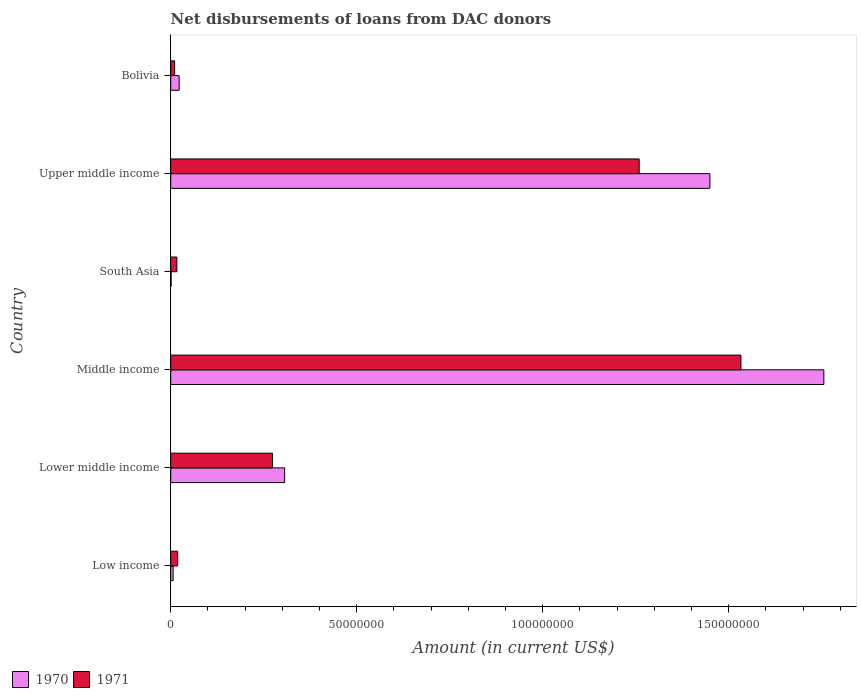Are the number of bars per tick equal to the number of legend labels?
Make the answer very short. Yes. How many bars are there on the 1st tick from the top?
Your answer should be compact. 2. How many bars are there on the 4th tick from the bottom?
Offer a very short reply. 2. What is the label of the 6th group of bars from the top?
Your answer should be very brief. Low income. In how many cases, is the number of bars for a given country not equal to the number of legend labels?
Your response must be concise. 0. What is the amount of loans disbursed in 1971 in Upper middle income?
Ensure brevity in your answer.  1.26e+08. Across all countries, what is the maximum amount of loans disbursed in 1970?
Your response must be concise. 1.76e+08. Across all countries, what is the minimum amount of loans disbursed in 1971?
Ensure brevity in your answer.  1.06e+06. In which country was the amount of loans disbursed in 1971 maximum?
Offer a very short reply. Middle income. What is the total amount of loans disbursed in 1970 in the graph?
Offer a terse response. 3.54e+08. What is the difference between the amount of loans disbursed in 1971 in Low income and that in Lower middle income?
Offer a terse response. -2.55e+07. What is the difference between the amount of loans disbursed in 1970 in Low income and the amount of loans disbursed in 1971 in Upper middle income?
Provide a short and direct response. -1.25e+08. What is the average amount of loans disbursed in 1970 per country?
Provide a short and direct response. 5.90e+07. What is the difference between the amount of loans disbursed in 1971 and amount of loans disbursed in 1970 in Middle income?
Provide a short and direct response. -2.23e+07. What is the ratio of the amount of loans disbursed in 1971 in Bolivia to that in Middle income?
Offer a terse response. 0.01. What is the difference between the highest and the second highest amount of loans disbursed in 1970?
Provide a succinct answer. 3.06e+07. What is the difference between the highest and the lowest amount of loans disbursed in 1971?
Provide a succinct answer. 1.52e+08. Is the sum of the amount of loans disbursed in 1971 in Lower middle income and Middle income greater than the maximum amount of loans disbursed in 1970 across all countries?
Keep it short and to the point. Yes. What does the 1st bar from the top in Bolivia represents?
Provide a short and direct response. 1971. What does the 2nd bar from the bottom in Lower middle income represents?
Keep it short and to the point. 1971. How many bars are there?
Keep it short and to the point. 12. Are all the bars in the graph horizontal?
Your answer should be very brief. Yes. How many countries are there in the graph?
Provide a succinct answer. 6. Does the graph contain any zero values?
Give a very brief answer. No. Does the graph contain grids?
Make the answer very short. No. Where does the legend appear in the graph?
Keep it short and to the point. Bottom left. What is the title of the graph?
Offer a terse response. Net disbursements of loans from DAC donors. What is the Amount (in current US$) in 1970 in Low income?
Make the answer very short. 6.47e+05. What is the Amount (in current US$) of 1971 in Low income?
Offer a very short reply. 1.86e+06. What is the Amount (in current US$) in 1970 in Lower middle income?
Provide a short and direct response. 3.06e+07. What is the Amount (in current US$) in 1971 in Lower middle income?
Your answer should be compact. 2.74e+07. What is the Amount (in current US$) of 1970 in Middle income?
Your answer should be compact. 1.76e+08. What is the Amount (in current US$) of 1971 in Middle income?
Make the answer very short. 1.53e+08. What is the Amount (in current US$) of 1970 in South Asia?
Your answer should be compact. 1.09e+05. What is the Amount (in current US$) in 1971 in South Asia?
Your answer should be very brief. 1.65e+06. What is the Amount (in current US$) of 1970 in Upper middle income?
Your answer should be compact. 1.45e+08. What is the Amount (in current US$) of 1971 in Upper middle income?
Offer a very short reply. 1.26e+08. What is the Amount (in current US$) of 1970 in Bolivia?
Make the answer very short. 2.27e+06. What is the Amount (in current US$) in 1971 in Bolivia?
Make the answer very short. 1.06e+06. Across all countries, what is the maximum Amount (in current US$) in 1970?
Make the answer very short. 1.76e+08. Across all countries, what is the maximum Amount (in current US$) in 1971?
Give a very brief answer. 1.53e+08. Across all countries, what is the minimum Amount (in current US$) in 1970?
Ensure brevity in your answer.  1.09e+05. Across all countries, what is the minimum Amount (in current US$) in 1971?
Your answer should be very brief. 1.06e+06. What is the total Amount (in current US$) in 1970 in the graph?
Ensure brevity in your answer.  3.54e+08. What is the total Amount (in current US$) in 1971 in the graph?
Offer a very short reply. 3.11e+08. What is the difference between the Amount (in current US$) in 1970 in Low income and that in Lower middle income?
Your response must be concise. -3.00e+07. What is the difference between the Amount (in current US$) of 1971 in Low income and that in Lower middle income?
Offer a very short reply. -2.55e+07. What is the difference between the Amount (in current US$) of 1970 in Low income and that in Middle income?
Your answer should be very brief. -1.75e+08. What is the difference between the Amount (in current US$) of 1971 in Low income and that in Middle income?
Keep it short and to the point. -1.51e+08. What is the difference between the Amount (in current US$) in 1970 in Low income and that in South Asia?
Keep it short and to the point. 5.38e+05. What is the difference between the Amount (in current US$) in 1971 in Low income and that in South Asia?
Your response must be concise. 2.09e+05. What is the difference between the Amount (in current US$) in 1970 in Low income and that in Upper middle income?
Provide a succinct answer. -1.44e+08. What is the difference between the Amount (in current US$) of 1971 in Low income and that in Upper middle income?
Provide a succinct answer. -1.24e+08. What is the difference between the Amount (in current US$) in 1970 in Low income and that in Bolivia?
Keep it short and to the point. -1.62e+06. What is the difference between the Amount (in current US$) in 1971 in Low income and that in Bolivia?
Your answer should be compact. 8.01e+05. What is the difference between the Amount (in current US$) of 1970 in Lower middle income and that in Middle income?
Your response must be concise. -1.45e+08. What is the difference between the Amount (in current US$) of 1971 in Lower middle income and that in Middle income?
Keep it short and to the point. -1.26e+08. What is the difference between the Amount (in current US$) in 1970 in Lower middle income and that in South Asia?
Keep it short and to the point. 3.05e+07. What is the difference between the Amount (in current US$) of 1971 in Lower middle income and that in South Asia?
Keep it short and to the point. 2.57e+07. What is the difference between the Amount (in current US$) in 1970 in Lower middle income and that in Upper middle income?
Offer a terse response. -1.14e+08. What is the difference between the Amount (in current US$) in 1971 in Lower middle income and that in Upper middle income?
Provide a succinct answer. -9.86e+07. What is the difference between the Amount (in current US$) in 1970 in Lower middle income and that in Bolivia?
Ensure brevity in your answer.  2.84e+07. What is the difference between the Amount (in current US$) in 1971 in Lower middle income and that in Bolivia?
Provide a succinct answer. 2.63e+07. What is the difference between the Amount (in current US$) in 1970 in Middle income and that in South Asia?
Ensure brevity in your answer.  1.75e+08. What is the difference between the Amount (in current US$) in 1971 in Middle income and that in South Asia?
Give a very brief answer. 1.52e+08. What is the difference between the Amount (in current US$) of 1970 in Middle income and that in Upper middle income?
Ensure brevity in your answer.  3.06e+07. What is the difference between the Amount (in current US$) of 1971 in Middle income and that in Upper middle income?
Offer a terse response. 2.74e+07. What is the difference between the Amount (in current US$) of 1970 in Middle income and that in Bolivia?
Provide a succinct answer. 1.73e+08. What is the difference between the Amount (in current US$) of 1971 in Middle income and that in Bolivia?
Provide a succinct answer. 1.52e+08. What is the difference between the Amount (in current US$) of 1970 in South Asia and that in Upper middle income?
Your response must be concise. -1.45e+08. What is the difference between the Amount (in current US$) in 1971 in South Asia and that in Upper middle income?
Your answer should be very brief. -1.24e+08. What is the difference between the Amount (in current US$) of 1970 in South Asia and that in Bolivia?
Provide a short and direct response. -2.16e+06. What is the difference between the Amount (in current US$) of 1971 in South Asia and that in Bolivia?
Your answer should be very brief. 5.92e+05. What is the difference between the Amount (in current US$) in 1970 in Upper middle income and that in Bolivia?
Offer a very short reply. 1.43e+08. What is the difference between the Amount (in current US$) in 1971 in Upper middle income and that in Bolivia?
Your response must be concise. 1.25e+08. What is the difference between the Amount (in current US$) in 1970 in Low income and the Amount (in current US$) in 1971 in Lower middle income?
Ensure brevity in your answer.  -2.67e+07. What is the difference between the Amount (in current US$) in 1970 in Low income and the Amount (in current US$) in 1971 in Middle income?
Offer a terse response. -1.53e+08. What is the difference between the Amount (in current US$) in 1970 in Low income and the Amount (in current US$) in 1971 in South Asia?
Make the answer very short. -1.00e+06. What is the difference between the Amount (in current US$) of 1970 in Low income and the Amount (in current US$) of 1971 in Upper middle income?
Offer a terse response. -1.25e+08. What is the difference between the Amount (in current US$) of 1970 in Low income and the Amount (in current US$) of 1971 in Bolivia?
Give a very brief answer. -4.11e+05. What is the difference between the Amount (in current US$) of 1970 in Lower middle income and the Amount (in current US$) of 1971 in Middle income?
Give a very brief answer. -1.23e+08. What is the difference between the Amount (in current US$) of 1970 in Lower middle income and the Amount (in current US$) of 1971 in South Asia?
Keep it short and to the point. 2.90e+07. What is the difference between the Amount (in current US$) of 1970 in Lower middle income and the Amount (in current US$) of 1971 in Upper middle income?
Provide a succinct answer. -9.53e+07. What is the difference between the Amount (in current US$) in 1970 in Lower middle income and the Amount (in current US$) in 1971 in Bolivia?
Ensure brevity in your answer.  2.96e+07. What is the difference between the Amount (in current US$) in 1970 in Middle income and the Amount (in current US$) in 1971 in South Asia?
Your answer should be compact. 1.74e+08. What is the difference between the Amount (in current US$) in 1970 in Middle income and the Amount (in current US$) in 1971 in Upper middle income?
Keep it short and to the point. 4.96e+07. What is the difference between the Amount (in current US$) of 1970 in Middle income and the Amount (in current US$) of 1971 in Bolivia?
Your answer should be compact. 1.74e+08. What is the difference between the Amount (in current US$) in 1970 in South Asia and the Amount (in current US$) in 1971 in Upper middle income?
Ensure brevity in your answer.  -1.26e+08. What is the difference between the Amount (in current US$) of 1970 in South Asia and the Amount (in current US$) of 1971 in Bolivia?
Keep it short and to the point. -9.49e+05. What is the difference between the Amount (in current US$) of 1970 in Upper middle income and the Amount (in current US$) of 1971 in Bolivia?
Your answer should be compact. 1.44e+08. What is the average Amount (in current US$) in 1970 per country?
Ensure brevity in your answer.  5.90e+07. What is the average Amount (in current US$) of 1971 per country?
Provide a succinct answer. 5.19e+07. What is the difference between the Amount (in current US$) in 1970 and Amount (in current US$) in 1971 in Low income?
Ensure brevity in your answer.  -1.21e+06. What is the difference between the Amount (in current US$) in 1970 and Amount (in current US$) in 1971 in Lower middle income?
Offer a terse response. 3.27e+06. What is the difference between the Amount (in current US$) of 1970 and Amount (in current US$) of 1971 in Middle income?
Offer a very short reply. 2.23e+07. What is the difference between the Amount (in current US$) of 1970 and Amount (in current US$) of 1971 in South Asia?
Offer a terse response. -1.54e+06. What is the difference between the Amount (in current US$) of 1970 and Amount (in current US$) of 1971 in Upper middle income?
Your answer should be compact. 1.90e+07. What is the difference between the Amount (in current US$) of 1970 and Amount (in current US$) of 1971 in Bolivia?
Make the answer very short. 1.21e+06. What is the ratio of the Amount (in current US$) in 1970 in Low income to that in Lower middle income?
Give a very brief answer. 0.02. What is the ratio of the Amount (in current US$) in 1971 in Low income to that in Lower middle income?
Keep it short and to the point. 0.07. What is the ratio of the Amount (in current US$) of 1970 in Low income to that in Middle income?
Offer a very short reply. 0. What is the ratio of the Amount (in current US$) of 1971 in Low income to that in Middle income?
Make the answer very short. 0.01. What is the ratio of the Amount (in current US$) of 1970 in Low income to that in South Asia?
Make the answer very short. 5.94. What is the ratio of the Amount (in current US$) of 1971 in Low income to that in South Asia?
Your answer should be very brief. 1.13. What is the ratio of the Amount (in current US$) in 1970 in Low income to that in Upper middle income?
Offer a very short reply. 0. What is the ratio of the Amount (in current US$) in 1971 in Low income to that in Upper middle income?
Offer a terse response. 0.01. What is the ratio of the Amount (in current US$) in 1970 in Low income to that in Bolivia?
Offer a very short reply. 0.28. What is the ratio of the Amount (in current US$) of 1971 in Low income to that in Bolivia?
Ensure brevity in your answer.  1.76. What is the ratio of the Amount (in current US$) of 1970 in Lower middle income to that in Middle income?
Offer a terse response. 0.17. What is the ratio of the Amount (in current US$) in 1971 in Lower middle income to that in Middle income?
Your response must be concise. 0.18. What is the ratio of the Amount (in current US$) in 1970 in Lower middle income to that in South Asia?
Your response must be concise. 280.94. What is the ratio of the Amount (in current US$) of 1971 in Lower middle income to that in South Asia?
Give a very brief answer. 16.58. What is the ratio of the Amount (in current US$) in 1970 in Lower middle income to that in Upper middle income?
Make the answer very short. 0.21. What is the ratio of the Amount (in current US$) of 1971 in Lower middle income to that in Upper middle income?
Offer a very short reply. 0.22. What is the ratio of the Amount (in current US$) of 1970 in Lower middle income to that in Bolivia?
Offer a very short reply. 13.49. What is the ratio of the Amount (in current US$) in 1971 in Lower middle income to that in Bolivia?
Your answer should be very brief. 25.85. What is the ratio of the Amount (in current US$) in 1970 in Middle income to that in South Asia?
Keep it short and to the point. 1610.58. What is the ratio of the Amount (in current US$) of 1971 in Middle income to that in South Asia?
Your answer should be compact. 92.89. What is the ratio of the Amount (in current US$) in 1970 in Middle income to that in Upper middle income?
Ensure brevity in your answer.  1.21. What is the ratio of the Amount (in current US$) in 1971 in Middle income to that in Upper middle income?
Provide a short and direct response. 1.22. What is the ratio of the Amount (in current US$) of 1970 in Middle income to that in Bolivia?
Offer a terse response. 77.34. What is the ratio of the Amount (in current US$) of 1971 in Middle income to that in Bolivia?
Provide a short and direct response. 144.87. What is the ratio of the Amount (in current US$) of 1970 in South Asia to that in Upper middle income?
Offer a terse response. 0. What is the ratio of the Amount (in current US$) of 1971 in South Asia to that in Upper middle income?
Provide a short and direct response. 0.01. What is the ratio of the Amount (in current US$) in 1970 in South Asia to that in Bolivia?
Offer a very short reply. 0.05. What is the ratio of the Amount (in current US$) in 1971 in South Asia to that in Bolivia?
Offer a terse response. 1.56. What is the ratio of the Amount (in current US$) in 1970 in Upper middle income to that in Bolivia?
Your response must be concise. 63.85. What is the ratio of the Amount (in current US$) of 1971 in Upper middle income to that in Bolivia?
Ensure brevity in your answer.  119.02. What is the difference between the highest and the second highest Amount (in current US$) of 1970?
Keep it short and to the point. 3.06e+07. What is the difference between the highest and the second highest Amount (in current US$) of 1971?
Offer a very short reply. 2.74e+07. What is the difference between the highest and the lowest Amount (in current US$) of 1970?
Provide a succinct answer. 1.75e+08. What is the difference between the highest and the lowest Amount (in current US$) of 1971?
Keep it short and to the point. 1.52e+08. 